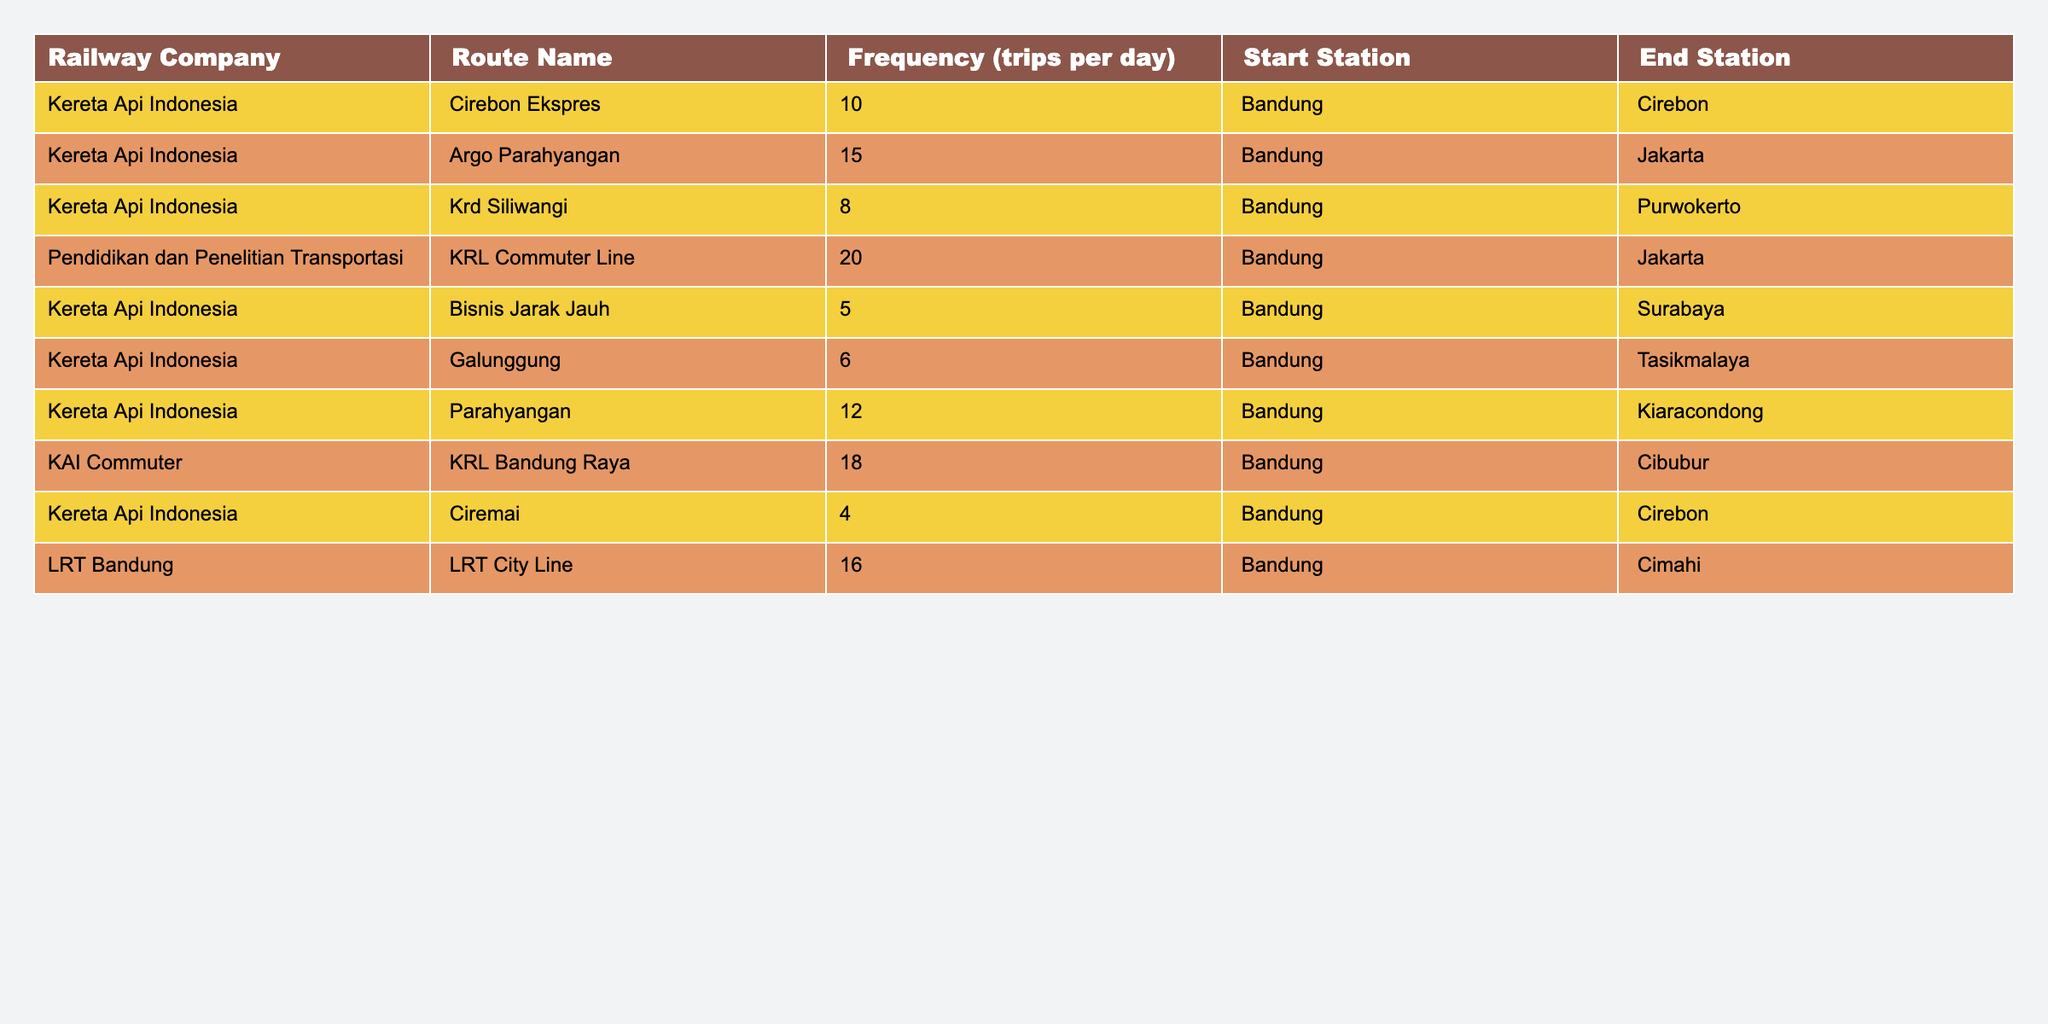What is the most frequent train route operated by Kereta Api Indonesia? By looking at the table, we can see that the highest frequency of trips for Kereta Api Indonesia is for the Argo Parahyangan route, which operates 15 trips per day.
Answer: 15 How many trips does the KRL Commuter Line operate per day? The table indicates that the KRL Commuter Line operated by Pendidikan dan Penelitian Transportasi has a frequency of 20 trips per day.
Answer: 20 What is the total frequency of trips per day for the routes that start from Bandung? By summing up the frequencies of all routes starting from Bandung, we have: 10 + 15 + 8 + 20 + 5 + 6 + 12 + 18 + 4 + 16 = 114 trips per day.
Answer: 114 Which route has the fewer number of trips, and how many does it have? The route with the lowest number of trips is Ciremai, operated by Kereta Api Indonesia, with only 4 trips per day.
Answer: 4 Is there a route with more than 15 trips per day? Yes, the KRL Commuter Line, operated by Pendidikan dan Penelitian Transportasi, has 20 trips per day, which is more than 15.
Answer: Yes Which operator provides the widest range of train frequencies? By inspecting the frequencies from various operators, Kereta Api Indonesia has the most varied frequencies (4 to 15 trips). This indicates a broader range compared to the other operators in the table.
Answer: Kereta Api Indonesia What is the average frequency of trips for all routes listed? The total number of trips is 114 (from the total frequency calculation), and there are 10 routes. Thus, the average frequency is 114/10 = 11.4.
Answer: 11.4 Which route between Cirebon and Surabaya has more daily trips? Cirebon Ekspres has 10 trips to Cirebon, and Bisnis Jarak Jauh has 5 trips to Surabaya. Therefore, Cirebon Ekspres has more trips.
Answer: Cirebon Ekspres What percentage of the total daily trips are operated by the KAI Commuter? The KAI Commuter has a frequency of 18 trips per day. Given the total of 114 trips, we calculate (18/114) * 100 = 15.79%, which rounds to approximately 16%.
Answer: 16% Which route is operated with the least frequency among LRT and KRL routes? The routes for LRT and KRL show that KRL Ciremai has 4 trips, while LRT City Line has 16 trips. Therefore, Ciremai has the least frequency.
Answer: Ciremai 